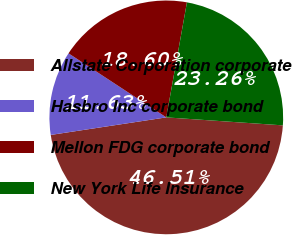<chart> <loc_0><loc_0><loc_500><loc_500><pie_chart><fcel>Allstate Corporation corporate<fcel>Hasbro Inc corporate bond<fcel>Mellon FDG corporate bond<fcel>New York Life Insurance<nl><fcel>46.51%<fcel>11.63%<fcel>18.6%<fcel>23.26%<nl></chart> 